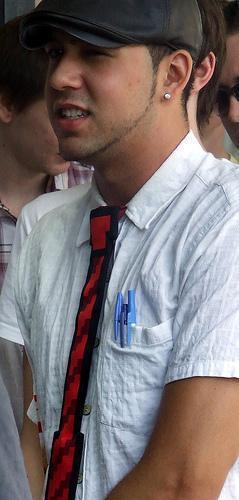How many pens are in the man's pocket?
Give a very brief answer. 3. 